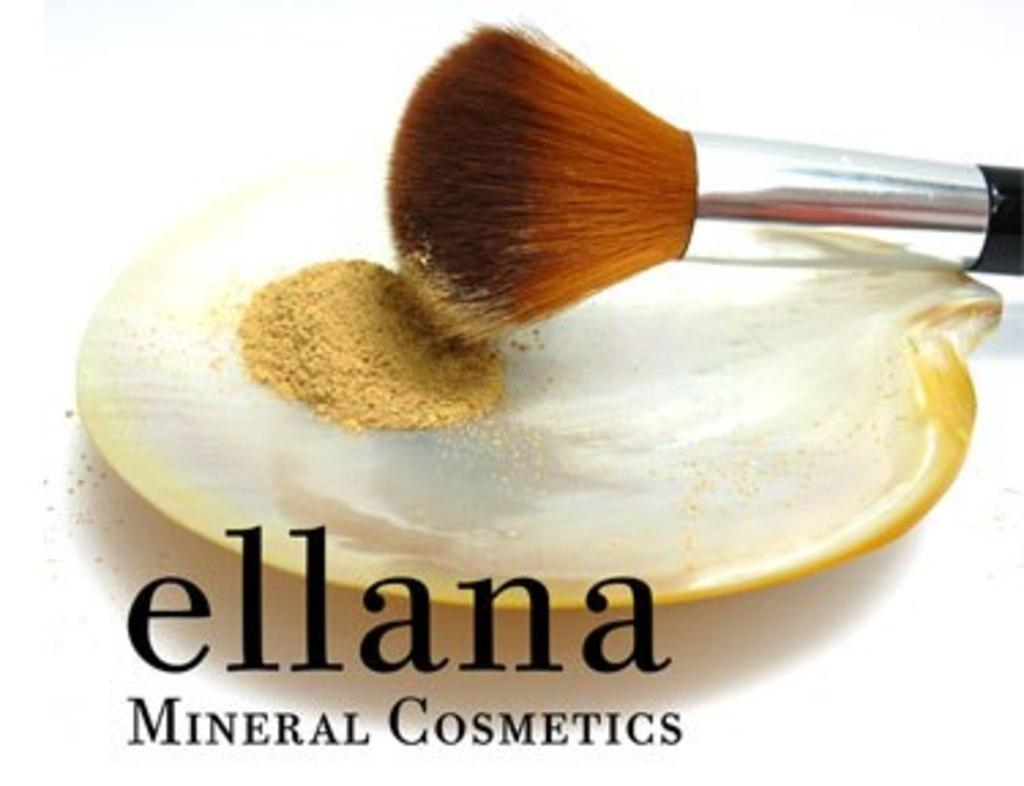<image>
Describe the image concisely. A makeup brush is dipped in powder advertising ellana mineral cosmetics. 